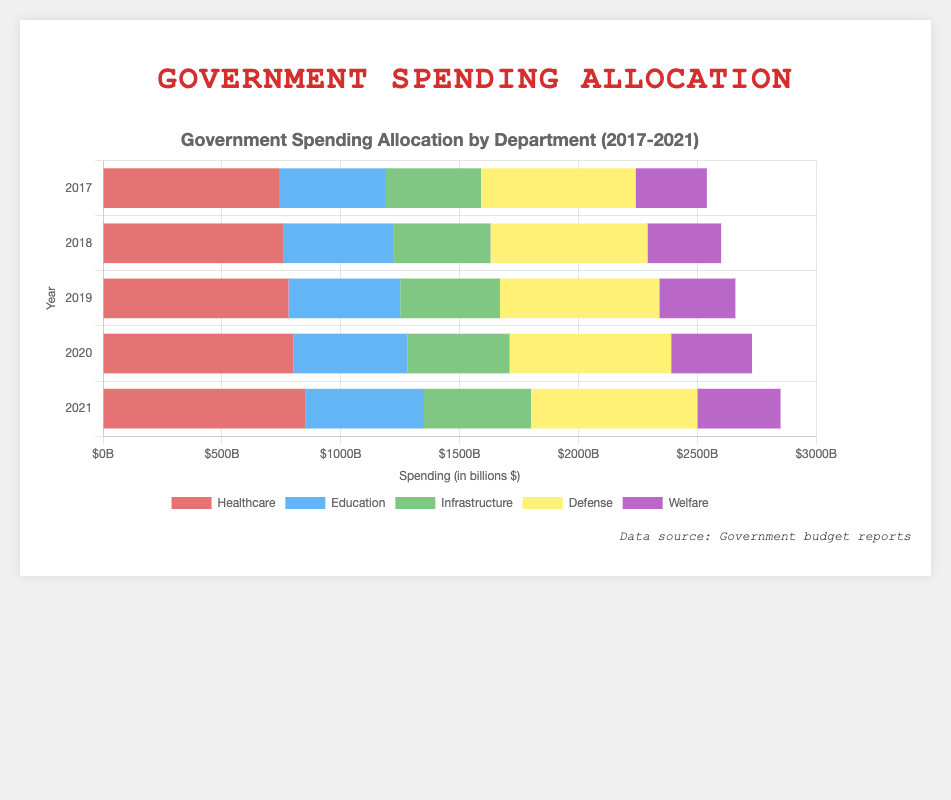What is the sum of spending on Healthcare and Defense in 2021? In 2021, the spending on Healthcare is 850 billion and on Defense is 700 billion. The sum is calculated by adding these two amounts: 850 + 700 = 1550 billion.
Answer: 1550 billion Which department saw the highest increase in spending from 2020 to 2021? Comparing the spending from 2020 to 2021 for each department: Healthcare increased by (850 - 800) = 50 billion, Education by (500 - 480) = 20 billion, Infrastructure by (450 - 430) = 20 billion, Defense by (700 - 680) = 20 billion, and Welfare by (350 - 340) = 10 billion. The highest increase is in Healthcare.
Answer: Healthcare What is the trend in Education spending from 2017 to 2021? Observing the bars representing Education spending, it rises slightly from 450 billion in 2017 to 500 billion in 2021. The steps are: 450 (2017), 460 (2018), 470 (2019), 480 (2020), and finally, 500 (2021). There is a slow upward trend over these years.
Answer: Upward trend Compare the spending on Infrastructure and Welfare in 2019. Which department received more funding? From the 2019 data, Infrastructure received 420 billion whereas Welfare received 320 billion. Comparing these two values, 420 billion is greater than 320 billion, so Infrastructure received more funding.
Answer: Infrastructure How does the total government spending in 2018 compare to 2021? Summing up all departments' spending for 2018: Healthcare (760) + Education (460) + Infrastructure (410) + Defense (660) + Welfare (310) = 2600 billion. For 2021: Healthcare (850) + Education (500) + Infrastructure (450) + Defense (700) + Welfare (350) = 2850 billion. Comparing 2600 billion to 2850 billion, the total spending in 2021 is higher than in 2018.
Answer: 2021 has higher total spending Which department consistently had the lowest spending over the period 2017-2021? By examining each year's lowest spending department: 2017 (Welfare 300), 2018 (Welfare 310), 2019 (Welfare 320), 2020 (Welfare 340), 2021 (Welfare 350). Welfare consistently is the lowest in each year.
Answer: Welfare What is the combined total of Healthcare and Infrastructure spending in 2020? The spending in 2020 for Healthcare is 800 billion and Infrastructure is 430 billion. Their combined total is calculated as: 800 + 430 = 1230 billion.
Answer: 1230 billion By how much did Defense spending increase from 2017 to 2021? The Defense spending in 2017 is 650 billion, and in 2021 it is 700 billion. The increase is calculated by subtracting 2017 from 2021: 700 - 650 = 50 billion.
Answer: 50 billion Does the chart show any decreases in Healthcare spending for any year between 2017 and 2021? Observing each year's Healthcare spending: 2017 (740), 2018 (760), 2019 (780), 2020 (800), 2021 (850). There are no decreases; the spending increases every year.
Answer: No Which color represents Welfare spending in the chart? The legend in the chart indicates Welfare spending is represented by the color purple.
Answer: Purple 